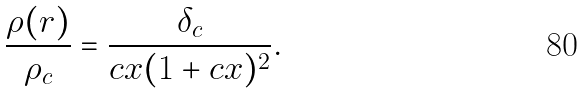Convert formula to latex. <formula><loc_0><loc_0><loc_500><loc_500>\frac { \rho ( r ) } { \rho _ { c } } = \frac { \delta _ { c } } { c x ( 1 + c x ) ^ { 2 } } .</formula> 